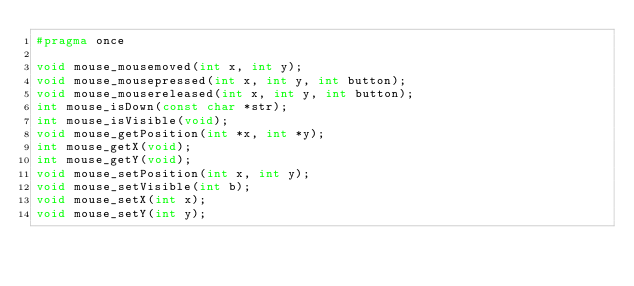Convert code to text. <code><loc_0><loc_0><loc_500><loc_500><_C_>#pragma once

void mouse_mousemoved(int x, int y);
void mouse_mousepressed(int x, int y, int button);
void mouse_mousereleased(int x, int y, int button);
int mouse_isDown(const char *str);
int mouse_isVisible(void);
void mouse_getPosition(int *x, int *y);
int mouse_getX(void);
int mouse_getY(void);
void mouse_setPosition(int x, int y);
void mouse_setVisible(int b);
void mouse_setX(int x);
void mouse_setY(int y);
</code> 